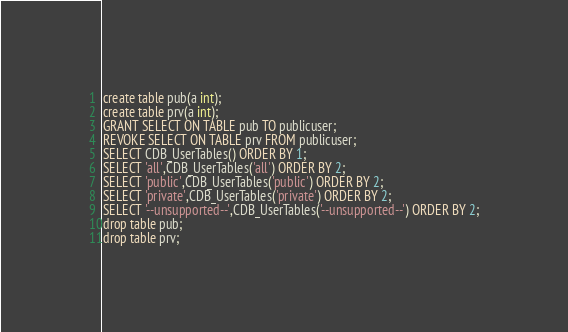<code> <loc_0><loc_0><loc_500><loc_500><_SQL_>create table pub(a int);
create table prv(a int);
GRANT SELECT ON TABLE pub TO publicuser;
REVOKE SELECT ON TABLE prv FROM publicuser;
SELECT CDB_UserTables() ORDER BY 1;
SELECT 'all',CDB_UserTables('all') ORDER BY 2;
SELECT 'public',CDB_UserTables('public') ORDER BY 2;
SELECT 'private',CDB_UserTables('private') ORDER BY 2;
SELECT '--unsupported--',CDB_UserTables('--unsupported--') ORDER BY 2;
drop table pub;
drop table prv;
</code> 